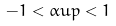<formula> <loc_0><loc_0><loc_500><loc_500>- 1 < \alpha u p < 1 \</formula> 